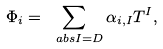<formula> <loc_0><loc_0><loc_500><loc_500>\Phi _ { i } = \sum _ { \ a b s { I } = D } \alpha _ { i , I } T ^ { I } ,</formula> 